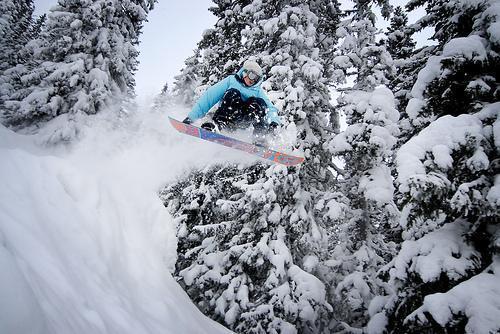How many people are in this picture?
Give a very brief answer. 1. 